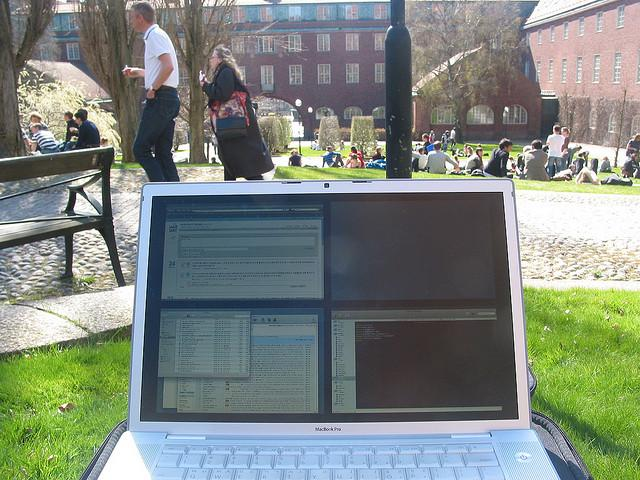Where is this lap top set up?

Choices:
A) fire house
B) church
C) school
D) cemetery school 